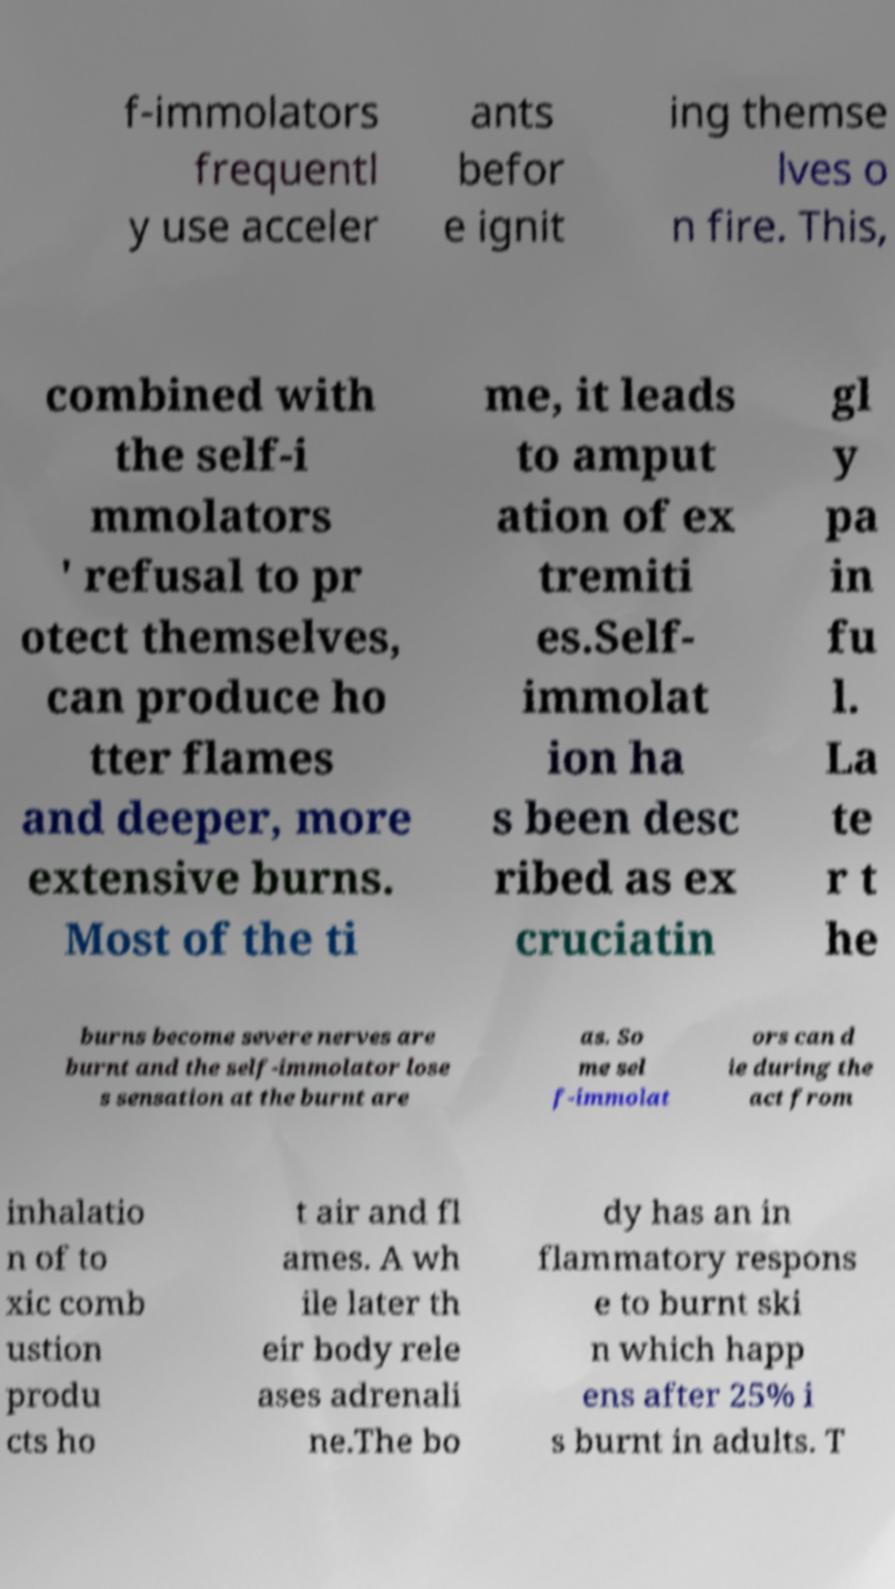Could you assist in decoding the text presented in this image and type it out clearly? f-immolators frequentl y use acceler ants befor e ignit ing themse lves o n fire. This, combined with the self-i mmolators ' refusal to pr otect themselves, can produce ho tter flames and deeper, more extensive burns. Most of the ti me, it leads to amput ation of ex tremiti es.Self- immolat ion ha s been desc ribed as ex cruciatin gl y pa in fu l. La te r t he burns become severe nerves are burnt and the self-immolator lose s sensation at the burnt are as. So me sel f-immolat ors can d ie during the act from inhalatio n of to xic comb ustion produ cts ho t air and fl ames. A wh ile later th eir body rele ases adrenali ne.The bo dy has an in flammatory respons e to burnt ski n which happ ens after 25% i s burnt in adults. T 